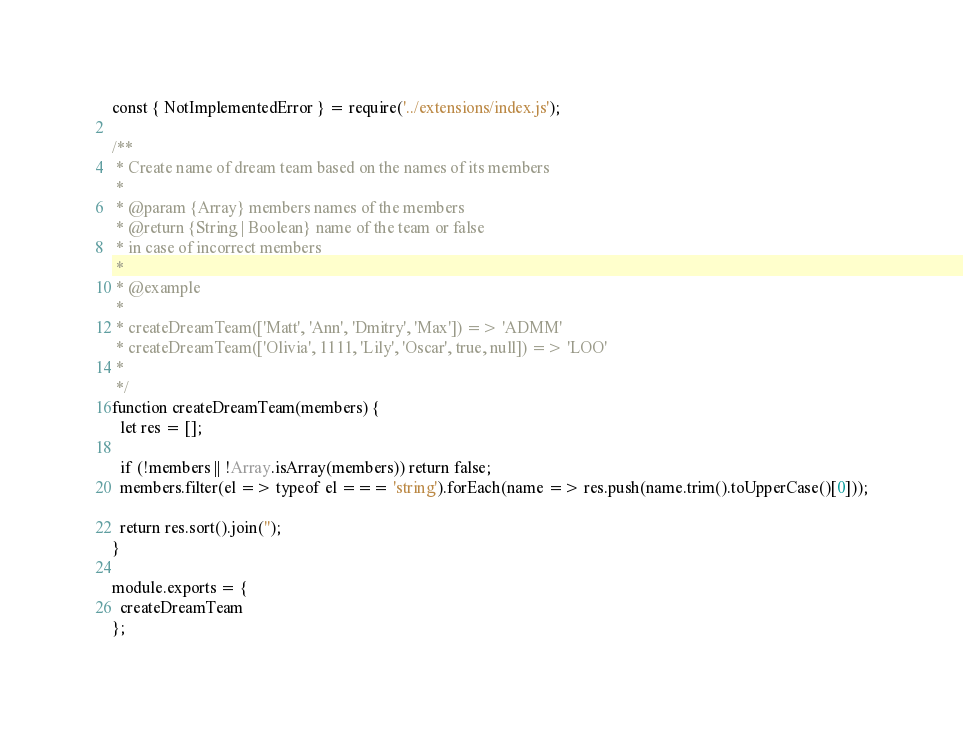<code> <loc_0><loc_0><loc_500><loc_500><_JavaScript_>const { NotImplementedError } = require('../extensions/index.js');

/**
 * Create name of dream team based on the names of its members
 *  
 * @param {Array} members names of the members 
 * @return {String | Boolean} name of the team or false
 * in case of incorrect members
 *
 * @example
 * 
 * createDreamTeam(['Matt', 'Ann', 'Dmitry', 'Max']) => 'ADMM'
 * createDreamTeam(['Olivia', 1111, 'Lily', 'Oscar', true, null]) => 'LOO'
 *
 */
function createDreamTeam(members) {
  let res = [];

  if (!members || !Array.isArray(members)) return false;
  members.filter(el => typeof el === 'string').forEach(name => res.push(name.trim().toUpperCase()[0]));

  return res.sort().join('');
}

module.exports = {
  createDreamTeam
};
</code> 